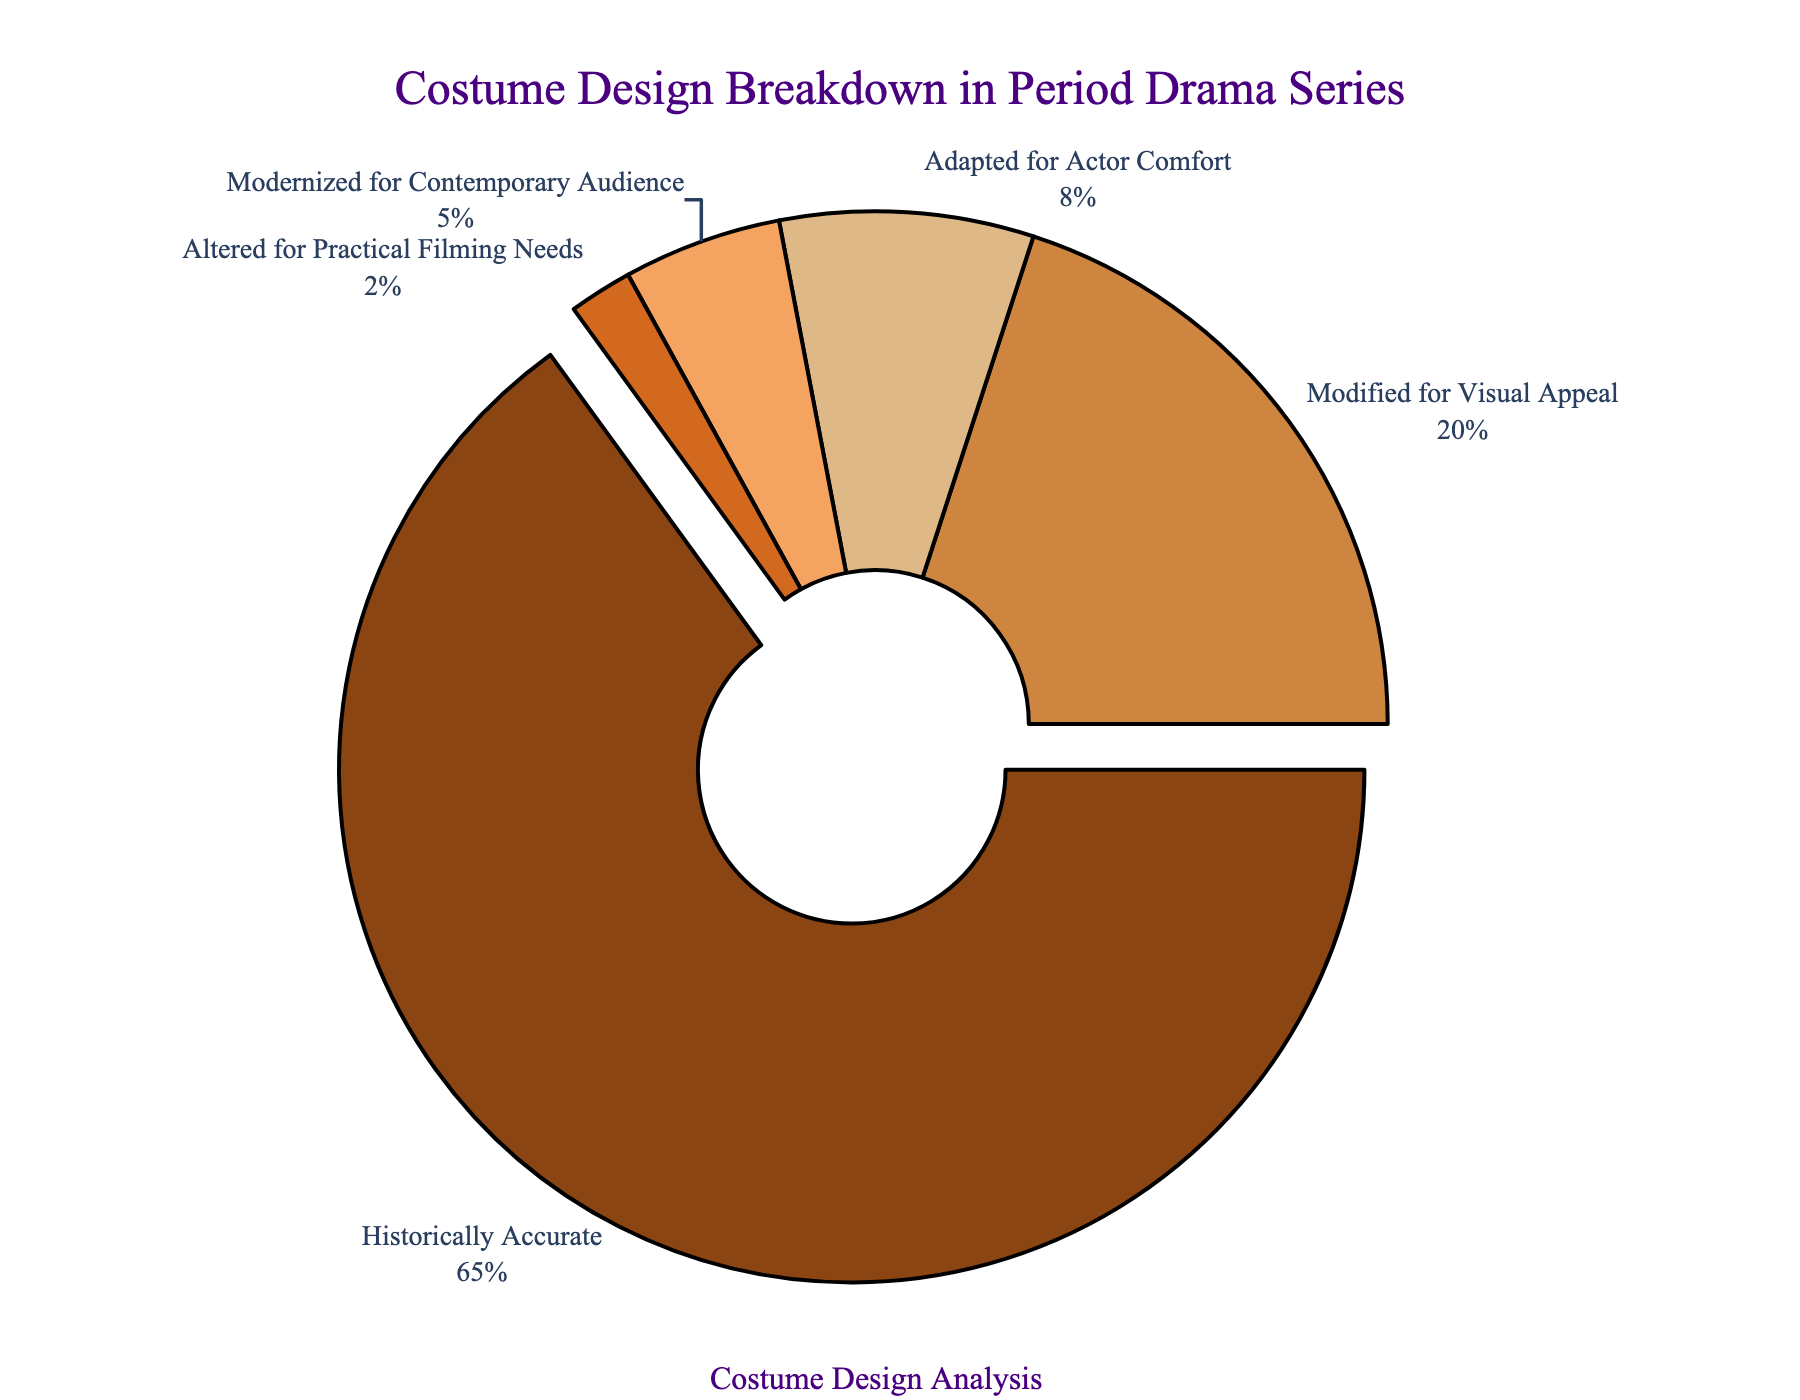How much of the total costume design is historically accurate? According to the pie chart, the slice labeled 'Historically Accurate' represents 65% of the total costume design.
Answer: 65% Which category has the least proportion of costume designs? Looking at the pie chart, the category with the smallest slice is 'Altered for Practical Filming Needs,' which is just 2%.
Answer: Altered for Practical Filming Needs What's the combined proportion of costume designs that are either modernized for contemporary audience or adapted for actor comfort? Summing up the percentages for 'Modernized for Contemporary Audience' (5%) and 'Adapted for Actor Comfort' (8%), we get 5% + 8% = 13%.
Answer: 13% Are historically accurate costumes more than three times the proportion of those modernized for a contemporary audience? Comparing 65% (Historically Accurate) and 5% (Modernized for Contemporary Audience), we find that 65% is indeed more than three times 5% (3 * 5% = 15%).
Answer: Yes Which category of costume design occupies substantially more space in the pie chart compared to 'Modified for Visual Appeal'? 'Historically Accurate' has a much larger slice at 65%, significantly more than 'Modified for Visual Appeal,' which has 20%.
Answer: Historically Accurate If the 'Adapted for Actor Comfort' category increased by 4%, what would its new proportion be? The current proportion of 'Adapted for Actor Comfort' is 8%. Adding 4%, we get 8% + 4% = 12%.
Answer: 12% Which categories combined make up less than a third of the total costume designs? Adding 'Adapted for Actor Comfort' (8%), 'Modernized for Contemporary Audience' (5%), and 'Altered for Practical Filming Needs' (2%), we get 8% + 5% + 2% = 15%, which is less than 33.3% (a third).
Answer: Adapted for Actor Comfort, Modernized for Contemporary Audience, Altered for Practical Filming Needs What is the difference in percentage between historically accurate costumes and those modified for visual appeal? The percentage for 'Historically Accurate' is 65% and for 'Modified for Visual Appeal' is 20%. The difference is 65% - 20% = 45%.
Answer: 45% Is the proportion of 'Modified for Visual Appeal' greater than the combined proportion of 'Modernized for Contemporary Audience' and 'Altered for Practical Filming Needs'? The proportion of 'Modified for Visual Appeal' is 20%. The combined proportion of 'Modernized for Contemporary Audience' (5%) and 'Altered for Practical Filming Needs' (2%) is 5% + 2% = 7%, which is less than 20%.
Answer: Yes 